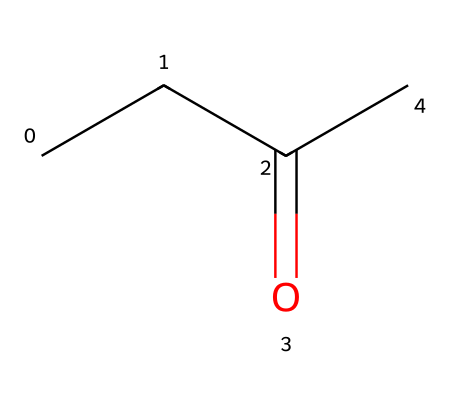What is the molecular formula of MEK? The SMILES representation depicts a molecule with 4 carbon (C) atoms, 8 hydrogen (H) atoms, and 1 oxygen (O) atom, leading to the molecular formula C4H8O.
Answer: C4H8O How many carbon atoms are present in MEK? By analyzing the SMILES structure, we identify that there are four 'C' symbols, indicating there are four carbon atoms in the molecule.
Answer: 4 What type of functional group does MEK contain? The presence of the C=O bond in the structure indicates the presence of a carbonyl group, which is characteristic of ketones.
Answer: carbonyl Is MEK a saturated or unsaturated compound? The absence of double or triple bonds between carbon atoms, aside from the C=O bond, indicates that MEK is a saturated compound.
Answer: saturated What is the key feature that classifies MEK as a ketone? The presence of a carbonyl group (C=O) flanked by carbon atoms on both sides is the specific characteristic that defines MEK as a ketone.
Answer: carbonyl group What is the total number of hydrogen atoms in MEK? The structure shows eight 'H' symbols, which accounts for the total number of hydrogen atoms in the molecule.
Answer: 8 What type of chemical reaction is commonly used to convert alcohols to ketones, such as in the formation of MEK? The oxidation reaction of secondary alcohols typically results in the formation of ketones, making it relevant to the synthesis of MEK.
Answer: oxidation 